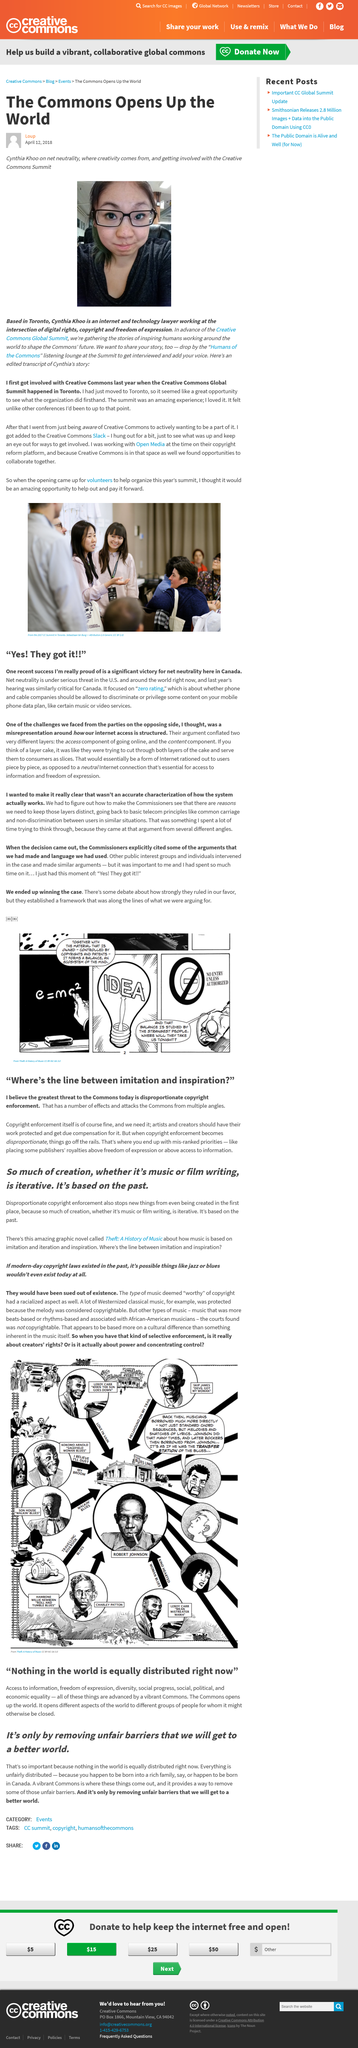Draw attention to some important aspects in this diagram. Cynthia Khoo is based in Toronto. According to the article, Canada achieved a significant victory for net neutrality. Everything in the world is unfairly distributed, and this is a fact that cannot be denied. I would go to the Humans of the Commons listening lounge to share my story of working around the world to shape the Commons' future, a platform where people can share their experiences and connect with others who share similar interests. We will create a better world by eliminating unfair barriers to achieve equality and justice for all. 